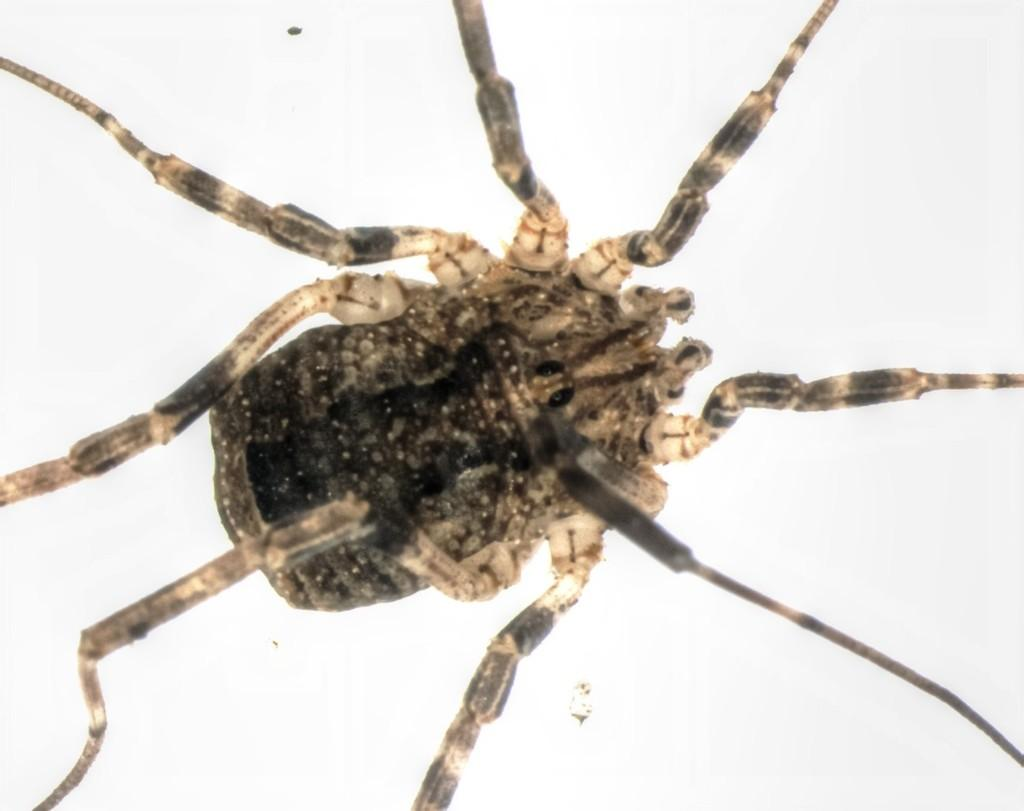What can be observed about the image that suggests it has been edited? The image appears to be edited, as it may have been altered or manipulated in some way. What is the main subject of the image? The main subject of the image is a spider. What type of science experiment can be seen in the image? There is no science experiment present in the image; it features a spider. What shape is the bridge in the image? There is no bridge present in the image. 